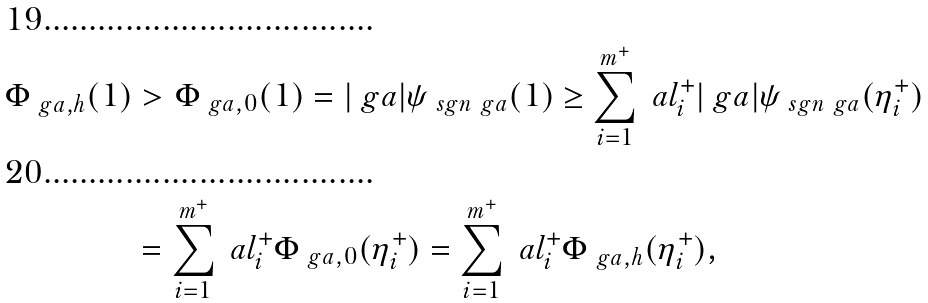<formula> <loc_0><loc_0><loc_500><loc_500>\Phi _ { \ g a , h } ( 1 ) & > \Phi _ { \ g a , 0 } ( 1 ) = | \ g a | \psi _ { \ s g n \ g a } ( 1 ) \geq \sum _ { i = 1 } ^ { m ^ { + } } \ a l _ { i } ^ { + } | \ g a | \psi _ { \ s g n \ g a } ( \eta _ { i } ^ { + } ) \\ & = \sum _ { i = 1 } ^ { m ^ { + } } \ a l _ { i } ^ { + } \Phi _ { \ g a , 0 } ( \eta _ { i } ^ { + } ) = \sum _ { i = 1 } ^ { m ^ { + } } \ a l _ { i } ^ { + } \Phi _ { \ g a , h } ( \eta _ { i } ^ { + } ) ,</formula> 